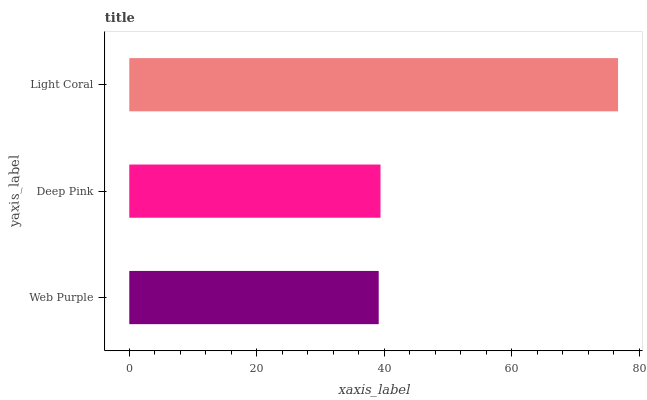Is Web Purple the minimum?
Answer yes or no. Yes. Is Light Coral the maximum?
Answer yes or no. Yes. Is Deep Pink the minimum?
Answer yes or no. No. Is Deep Pink the maximum?
Answer yes or no. No. Is Deep Pink greater than Web Purple?
Answer yes or no. Yes. Is Web Purple less than Deep Pink?
Answer yes or no. Yes. Is Web Purple greater than Deep Pink?
Answer yes or no. No. Is Deep Pink less than Web Purple?
Answer yes or no. No. Is Deep Pink the high median?
Answer yes or no. Yes. Is Deep Pink the low median?
Answer yes or no. Yes. Is Light Coral the high median?
Answer yes or no. No. Is Light Coral the low median?
Answer yes or no. No. 